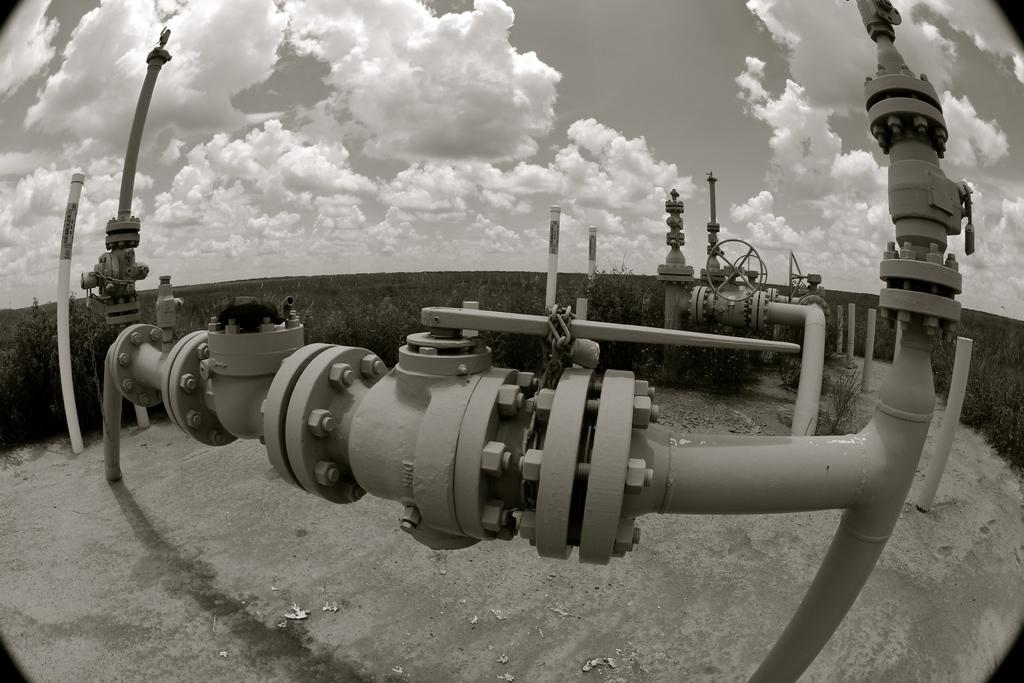What is the condition of the sky in the image? The sky is cloudy in the image. What type of vegetation can be seen in the image? There are plants in the image. What structures are present in the image? There are poles in the image. What type of equipment is visible in the image? Extension valves are present in the image. What small metal objects can be seen in the image? Bolt nuts are visible in the image. What type of note is the rat holding in the image? There is no rat or note present in the image. What does the person in the image regret? There is no person or regret present in the image. 